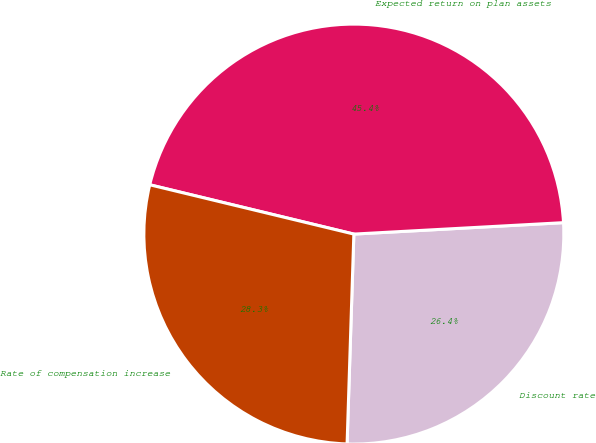<chart> <loc_0><loc_0><loc_500><loc_500><pie_chart><fcel>Discount rate<fcel>Expected return on plan assets<fcel>Rate of compensation increase<nl><fcel>26.38%<fcel>45.36%<fcel>28.26%<nl></chart> 